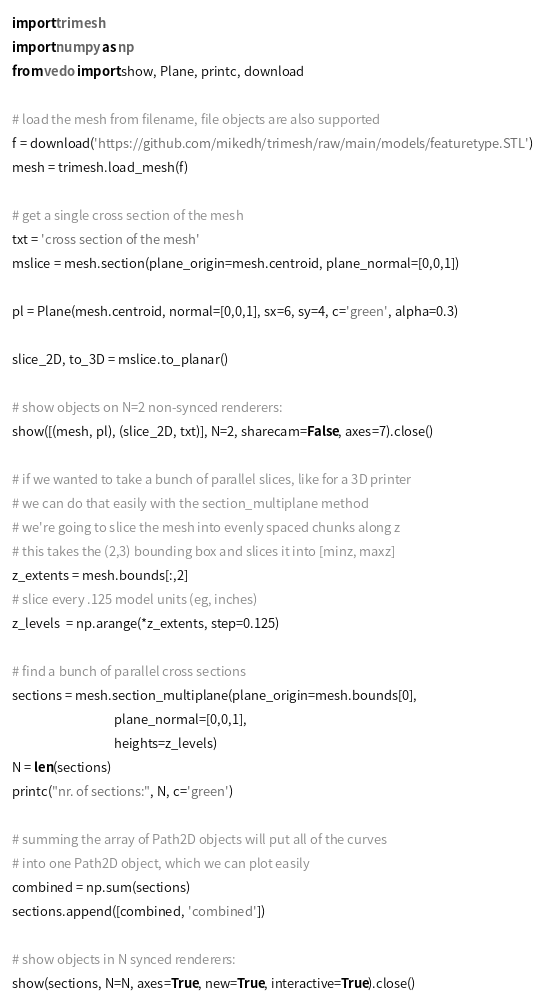<code> <loc_0><loc_0><loc_500><loc_500><_Python_>import trimesh
import numpy as np
from vedo import show, Plane, printc, download

# load the mesh from filename, file objects are also supported
f = download('https://github.com/mikedh/trimesh/raw/main/models/featuretype.STL')
mesh = trimesh.load_mesh(f)

# get a single cross section of the mesh
txt = 'cross section of the mesh'
mslice = mesh.section(plane_origin=mesh.centroid, plane_normal=[0,0,1])

pl = Plane(mesh.centroid, normal=[0,0,1], sx=6, sy=4, c='green', alpha=0.3)

slice_2D, to_3D = mslice.to_planar()

# show objects on N=2 non-synced renderers:
show([(mesh, pl), (slice_2D, txt)], N=2, sharecam=False, axes=7).close()

# if we wanted to take a bunch of parallel slices, like for a 3D printer
# we can do that easily with the section_multiplane method
# we're going to slice the mesh into evenly spaced chunks along z
# this takes the (2,3) bounding box and slices it into [minz, maxz]
z_extents = mesh.bounds[:,2]
# slice every .125 model units (eg, inches)
z_levels  = np.arange(*z_extents, step=0.125)

# find a bunch of parallel cross sections
sections = mesh.section_multiplane(plane_origin=mesh.bounds[0],
                                   plane_normal=[0,0,1],
                                   heights=z_levels)
N = len(sections)
printc("nr. of sections:", N, c='green')

# summing the array of Path2D objects will put all of the curves
# into one Path2D object, which we can plot easily
combined = np.sum(sections)
sections.append([combined, 'combined'])

# show objects in N synced renderers:
show(sections, N=N, axes=True, new=True, interactive=True).close()

</code> 